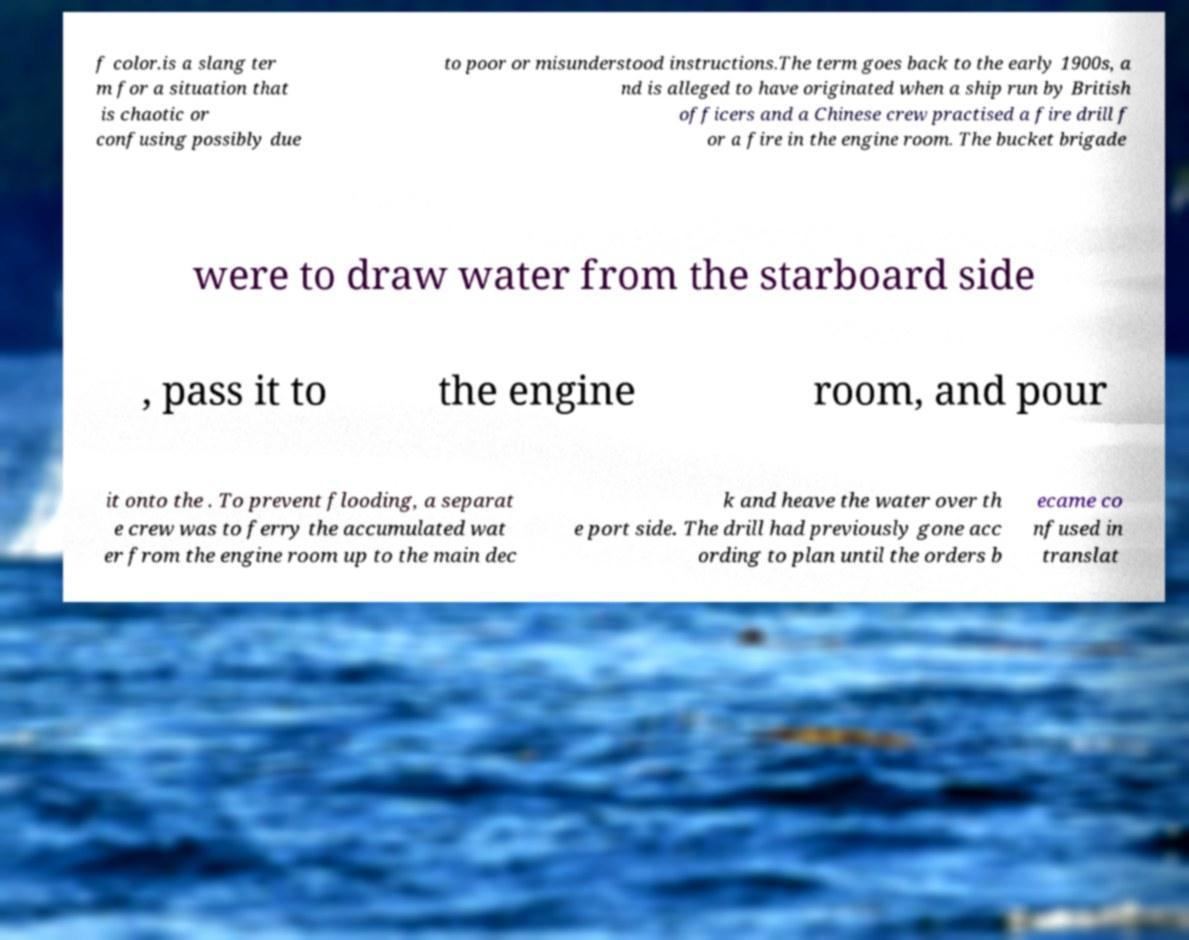Could you extract and type out the text from this image? f color.is a slang ter m for a situation that is chaotic or confusing possibly due to poor or misunderstood instructions.The term goes back to the early 1900s, a nd is alleged to have originated when a ship run by British officers and a Chinese crew practised a fire drill f or a fire in the engine room. The bucket brigade were to draw water from the starboard side , pass it to the engine room, and pour it onto the . To prevent flooding, a separat e crew was to ferry the accumulated wat er from the engine room up to the main dec k and heave the water over th e port side. The drill had previously gone acc ording to plan until the orders b ecame co nfused in translat 